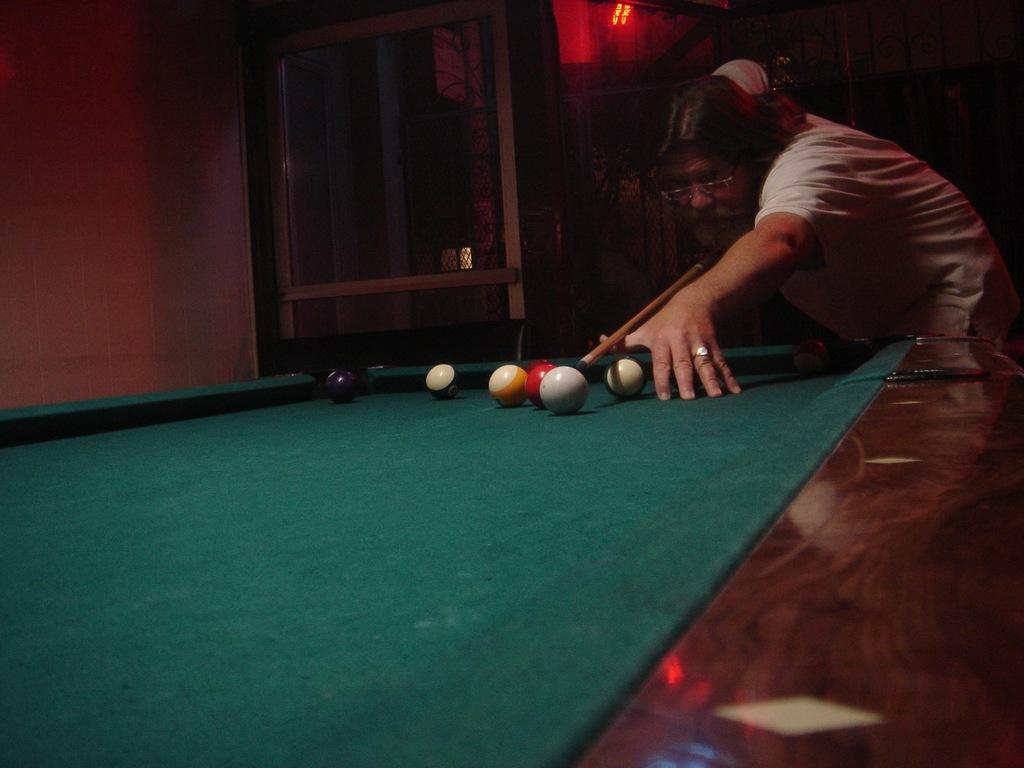What is the man in the image doing? The man is playing snooker in the image. What is the main object being used by the man in the image? The snooker board is present in the image. How would you describe the lighting in the room? The room is dark in the image. Is there any additional lighting in the room? Yes, there is a red light in the middle of the room. What type of quill is the man using to write on the print in the image? There is no quill or print present in the image; the man is playing snooker on a snooker board. How many buttons can be seen on the man's shirt in the image? There is no shirt visible in the image, as the man is wearing a snooker vest. 